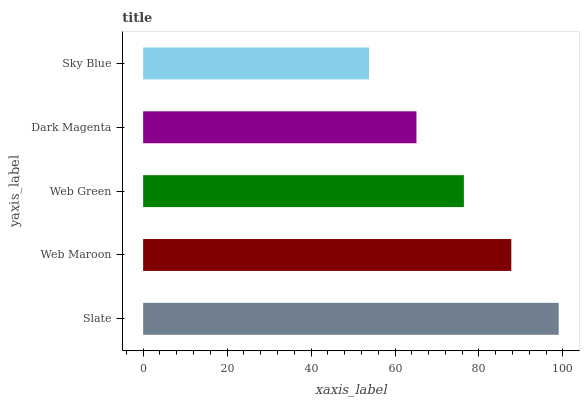Is Sky Blue the minimum?
Answer yes or no. Yes. Is Slate the maximum?
Answer yes or no. Yes. Is Web Maroon the minimum?
Answer yes or no. No. Is Web Maroon the maximum?
Answer yes or no. No. Is Slate greater than Web Maroon?
Answer yes or no. Yes. Is Web Maroon less than Slate?
Answer yes or no. Yes. Is Web Maroon greater than Slate?
Answer yes or no. No. Is Slate less than Web Maroon?
Answer yes or no. No. Is Web Green the high median?
Answer yes or no. Yes. Is Web Green the low median?
Answer yes or no. Yes. Is Slate the high median?
Answer yes or no. No. Is Sky Blue the low median?
Answer yes or no. No. 